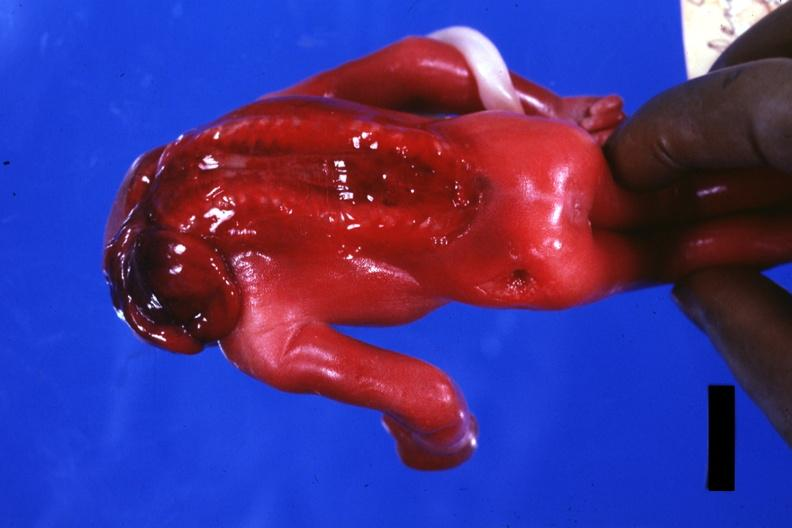does natural color show posterior view open cord?
Answer the question using a single word or phrase. No 